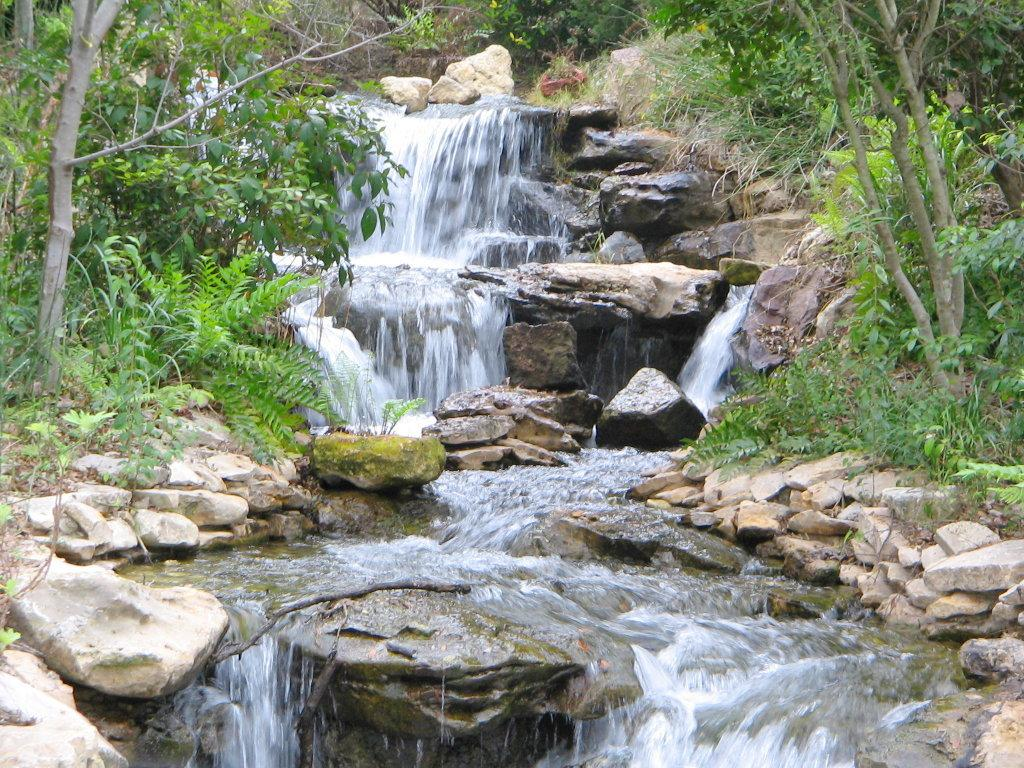What type of vegetation is present in the center of the image? There are trees in the center of the image. What type of ground cover is present in the center of the image? There is grass in the center of the image. What type of natural feature is present in the center of the image? There is water in the center of the image. What type of geological feature is present in the center of the image? There are rocks in the center of the image. What type of health advice can be seen written on the rocks in the image? There is no health advice written on the rocks in the image; the rocks are a geological feature. How many rats can be seen climbing the trees in the image? There are no rats present in the image; the image features trees, grass, water, and rocks. 